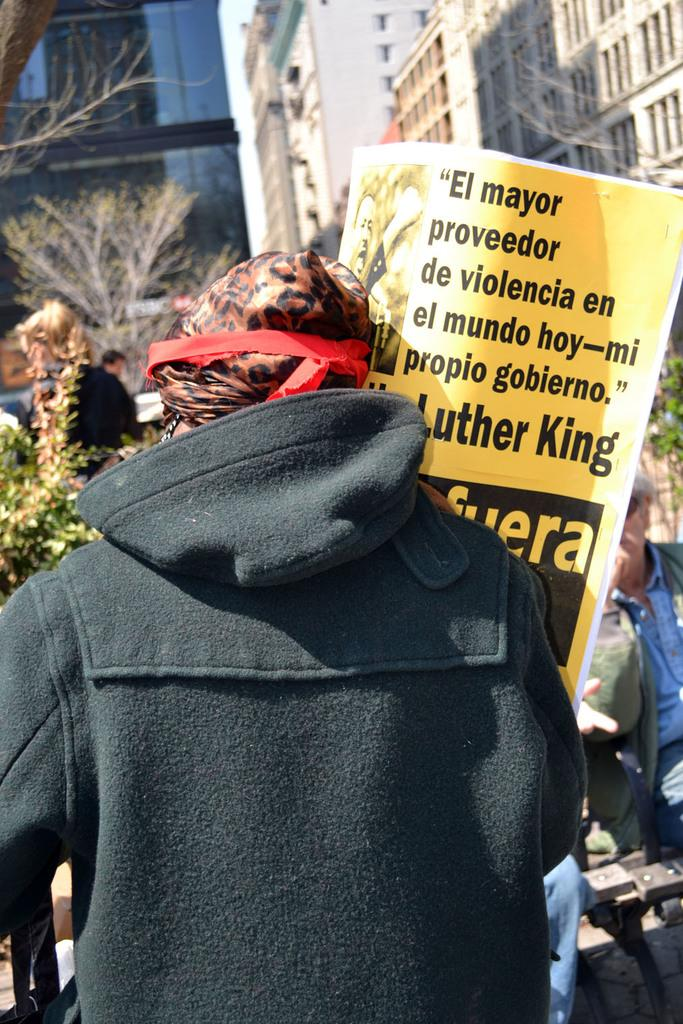What type of structures can be seen in the background of the image? There are buildings in the background of the image. What type of natural elements are present in the image? There are trees and plants in the image. Are there any living beings visible in the image? Yes, there are people in the image. What else can be seen in the image besides the people and natural elements? There are objects and a poster in the image. What type of metal is being observed in the image? There is no metal present in the image. What type of authority figure can be seen in the image? There is no authority figure present in the image. 